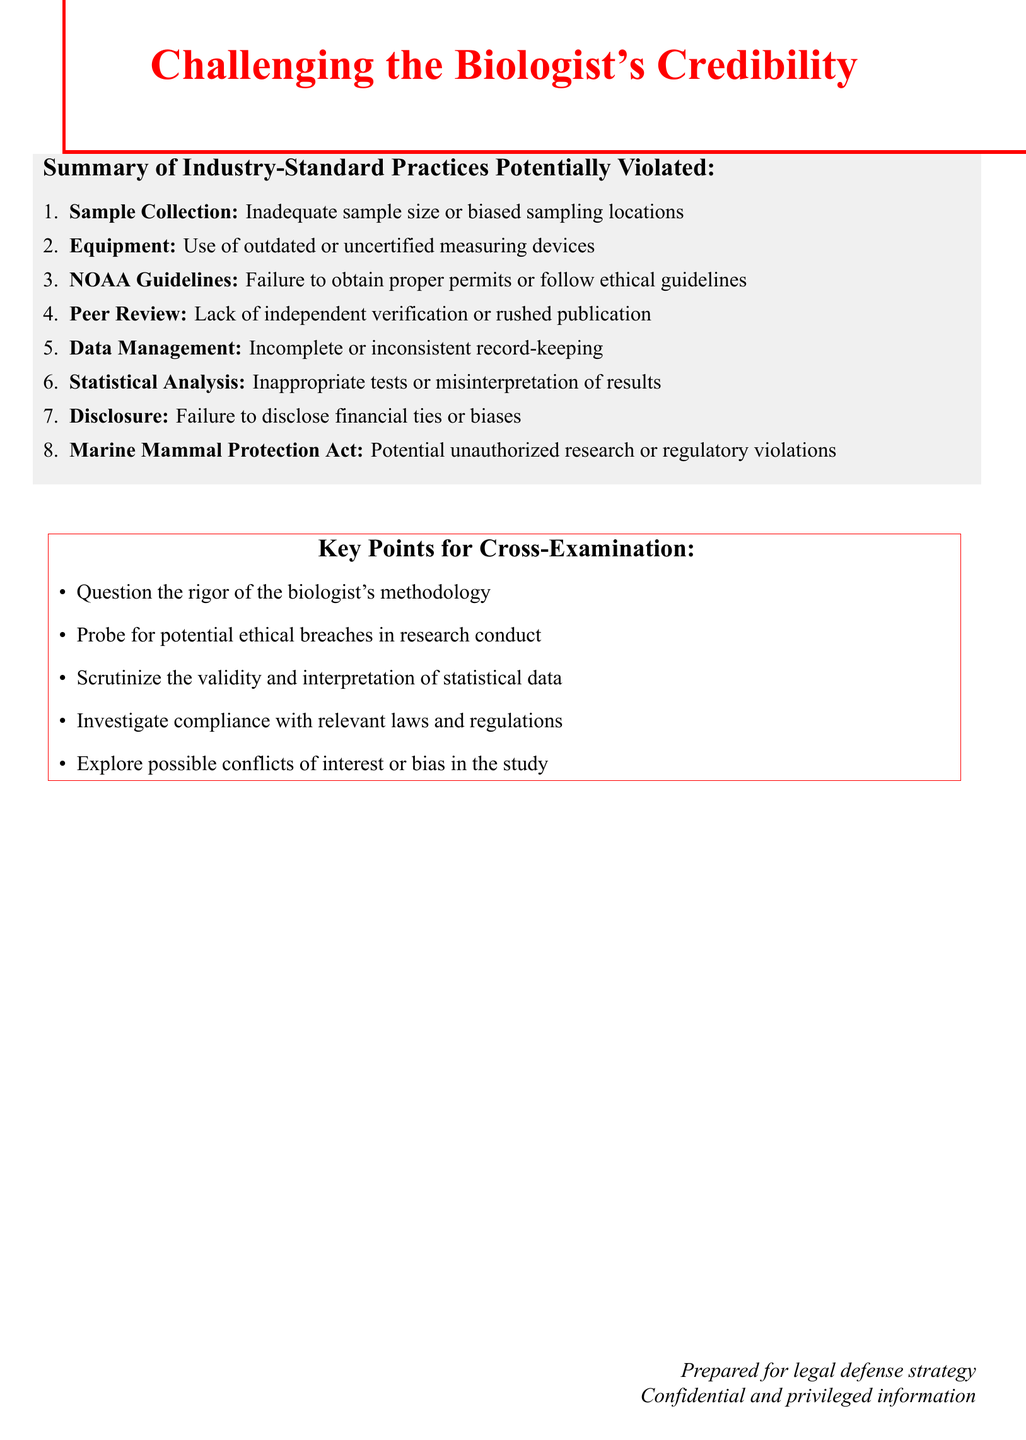What is the first industry-standard practice listed? The first industry-standard practice mentioned in the document is "Proper sample collection methods."
Answer: Proper sample collection methods What is one potential failure associated with the use of equipment? The document states that a potential failure related to equipment is "Utilization of outdated or uncertified measuring devices."
Answer: Utilization of outdated or uncertified measuring devices How many industry-standard practices are listed? The document enumerates a total of eight industry-standard practices.
Answer: Eight What is a key point for cross-examination regarding data management? According to the document, one key point for cross-examination is to "Scrutinize the validity and interpretation of statistical data."
Answer: Scrutinize the validity and interpretation of statistical data What compliance act is mentioned in the document? The document references the "Marine Mammal Protection Act."
Answer: Marine Mammal Protection Act What is one aspect of peer review that could be questioned? The document suggests questioning the "Lack of independent verification or rushed publication."
Answer: Lack of independent verification or rushed publication What are researchers required to disclose according to standard practices? The document specifies that researchers should disclose "funding sources and potential conflicts of interest."
Answer: funding sources and potential conflicts of interest What ethical guidelines does the document mention? The document states the need for adherence to "NOAA Fisheries' Guidelines for Marine Mammal Research."
Answer: NOAA Fisheries' Guidelines for Marine Mammal Research 